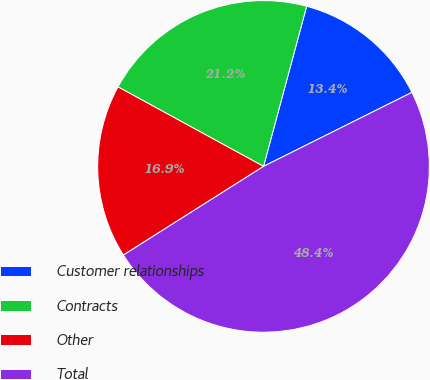Convert chart. <chart><loc_0><loc_0><loc_500><loc_500><pie_chart><fcel>Customer relationships<fcel>Contracts<fcel>Other<fcel>Total<nl><fcel>13.45%<fcel>21.23%<fcel>16.94%<fcel>48.39%<nl></chart> 